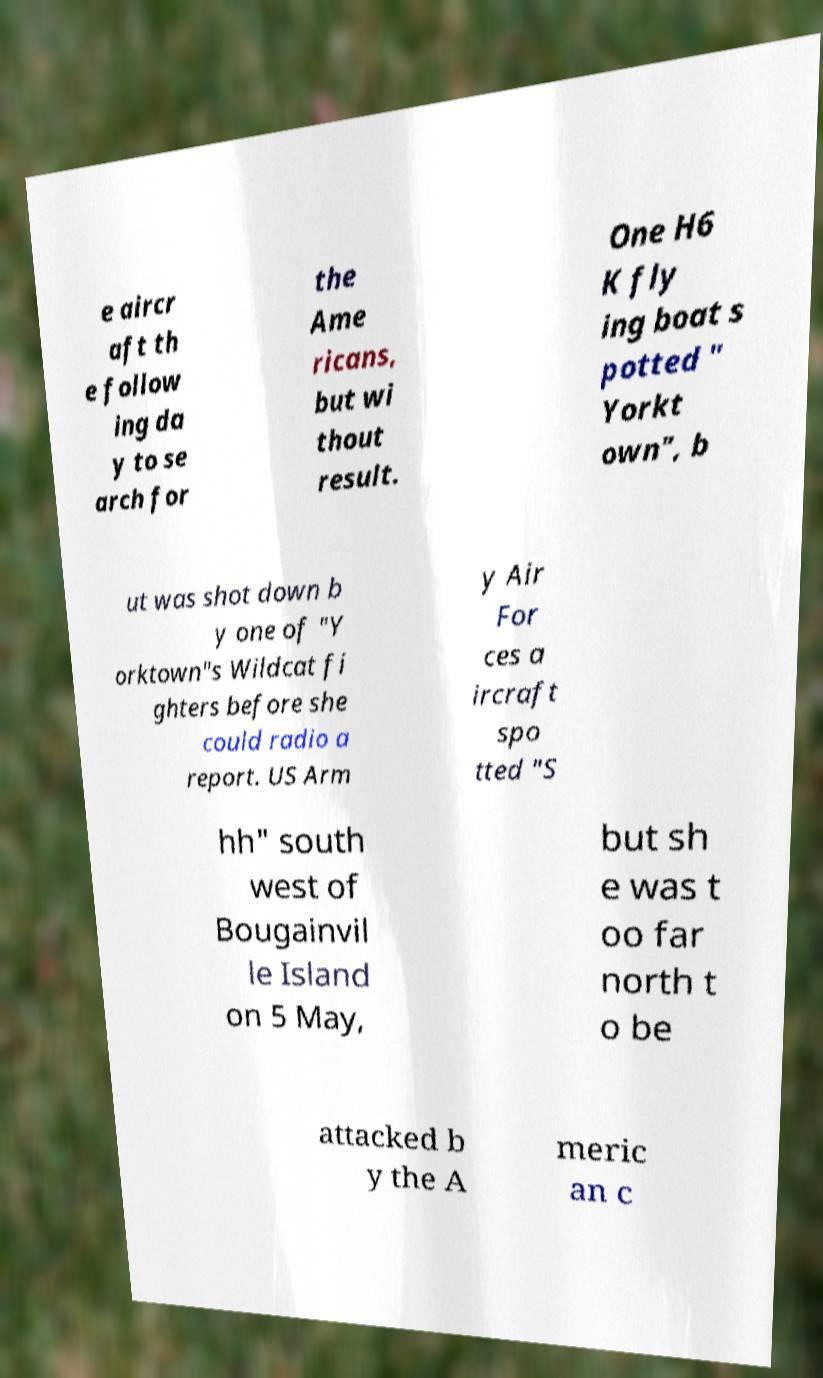Could you assist in decoding the text presented in this image and type it out clearly? e aircr aft th e follow ing da y to se arch for the Ame ricans, but wi thout result. One H6 K fly ing boat s potted " Yorkt own", b ut was shot down b y one of "Y orktown"s Wildcat fi ghters before she could radio a report. US Arm y Air For ces a ircraft spo tted "S hh" south west of Bougainvil le Island on 5 May, but sh e was t oo far north t o be attacked b y the A meric an c 